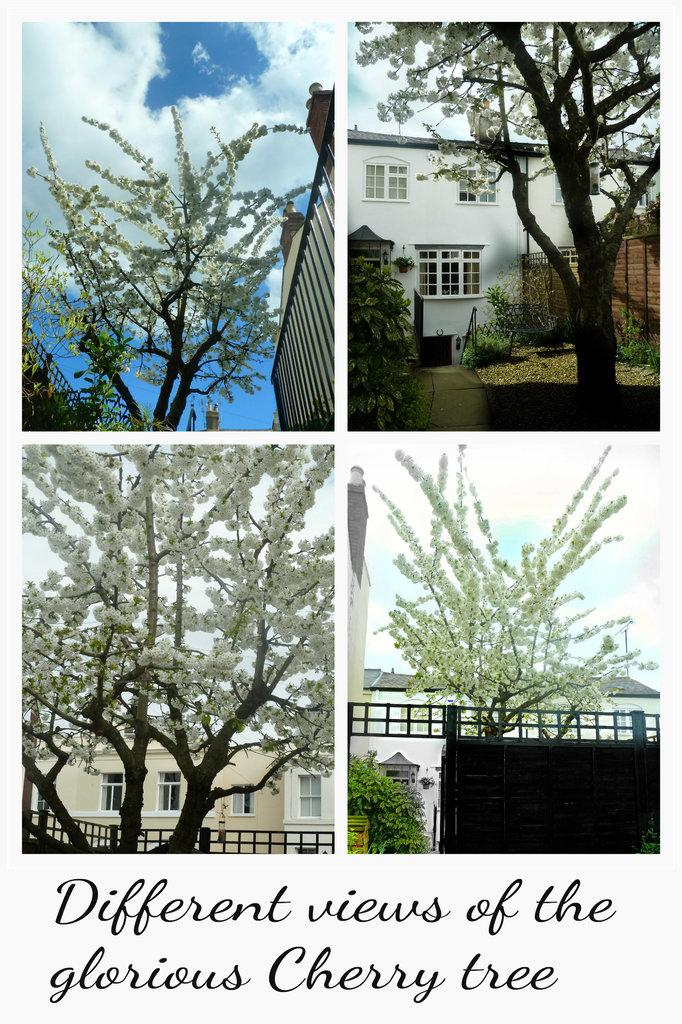What type of artwork is the image? The image is a collage. What can be seen in the sky in the image? Clouds are present in the image. What type of structures are visible in the image? There are buildings in the image. What type of vegetation is visible in the image? Trees are visible in the image. What architectural features can be seen in the image? Windows and railings are visible in the image. What is written at the bottom of the image? There is text at the bottom of the image. What type of card is being played by the friend in the image? There is no card or friend present in the image; it is a collage featuring various elements. 